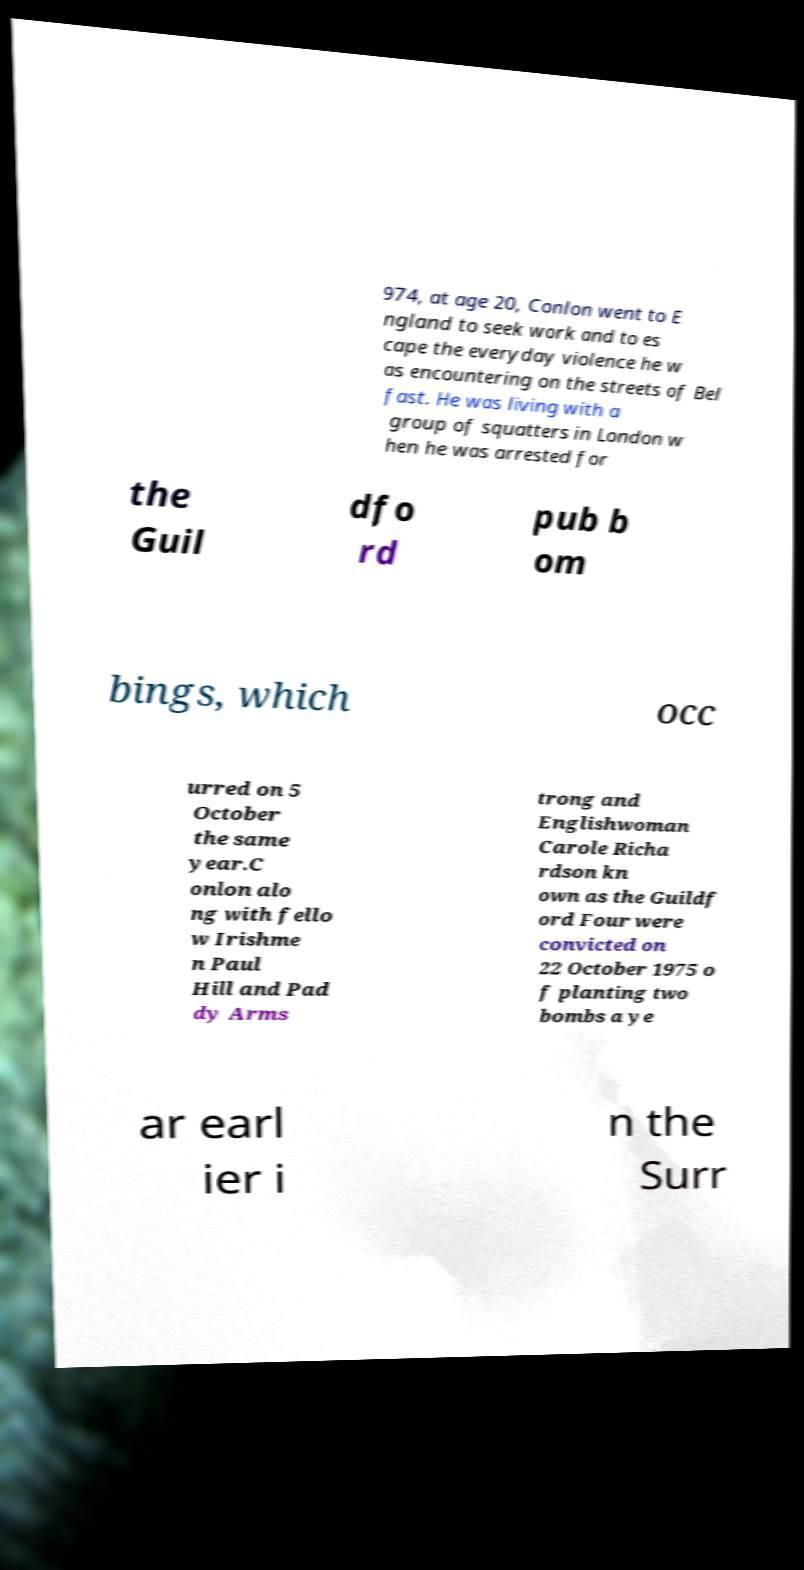Please read and relay the text visible in this image. What does it say? 974, at age 20, Conlon went to E ngland to seek work and to es cape the everyday violence he w as encountering on the streets of Bel fast. He was living with a group of squatters in London w hen he was arrested for the Guil dfo rd pub b om bings, which occ urred on 5 October the same year.C onlon alo ng with fello w Irishme n Paul Hill and Pad dy Arms trong and Englishwoman Carole Richa rdson kn own as the Guildf ord Four were convicted on 22 October 1975 o f planting two bombs a ye ar earl ier i n the Surr 